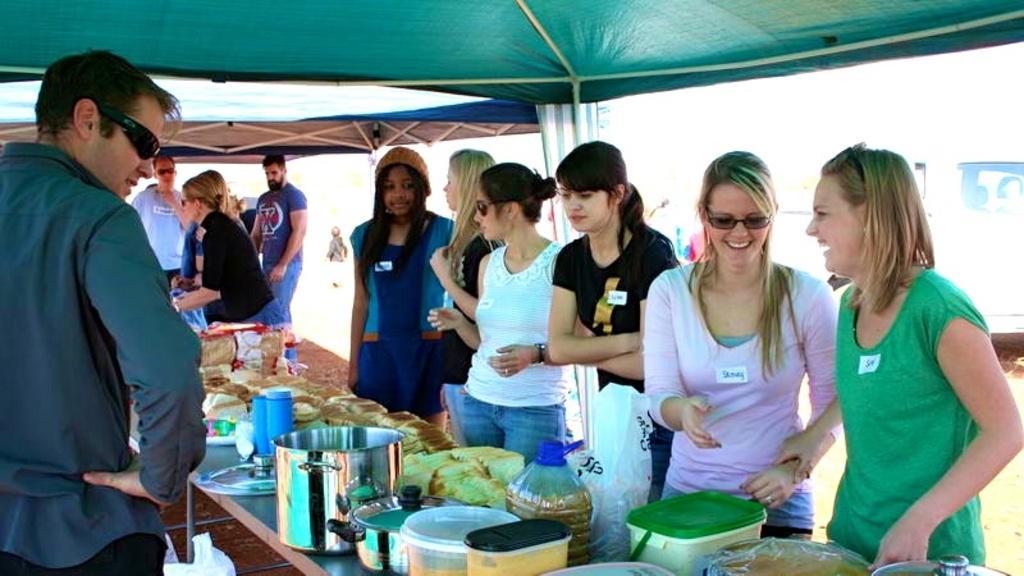Describe this image in one or two sentences. On the left side, there is a person in a shirt standing and smiling. On the right side, there are women in different color dresses standing. Some of them are smiling. In front of them, there are vessels, boxes, food packets and other objects. In the background, there are persons standing, there are tents and a vehicle. And the background is white in color. 